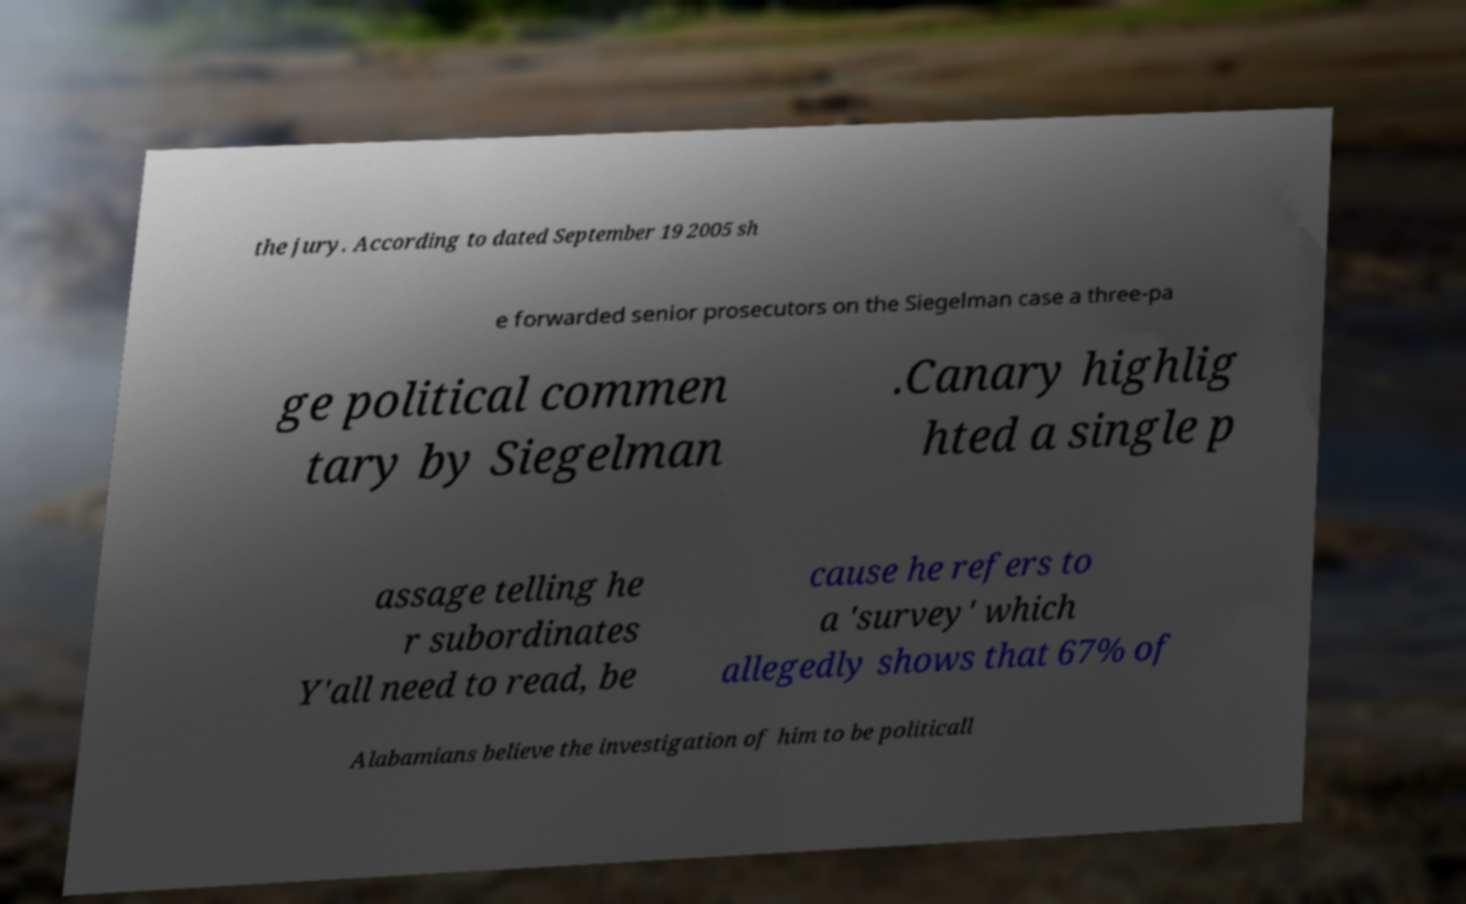What messages or text are displayed in this image? I need them in a readable, typed format. the jury. According to dated September 19 2005 sh e forwarded senior prosecutors on the Siegelman case a three-pa ge political commen tary by Siegelman .Canary highlig hted a single p assage telling he r subordinates Y'all need to read, be cause he refers to a 'survey' which allegedly shows that 67% of Alabamians believe the investigation of him to be politicall 